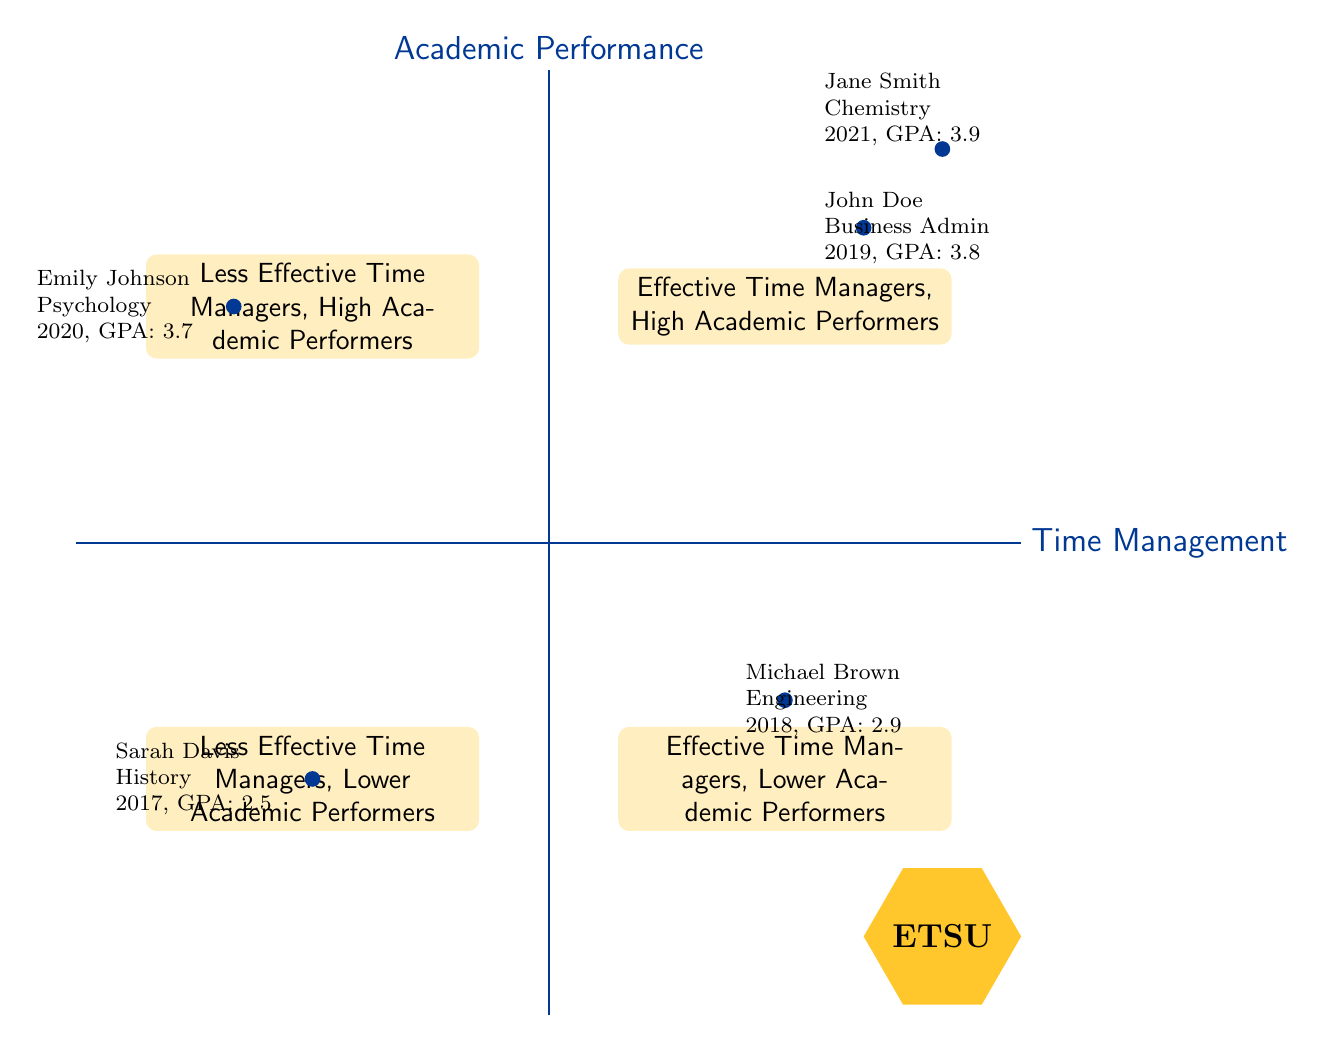What is the GPA of John Doe? According to the example provided in the Top-Right quadrant, John Doe's GPA is listed directly next to his name. Thus, the GPA information is clearly stated.
Answer: 3.8 Which quadrant contains Emily Johnson? Emily Johnson is located in the Top-Left quadrant, which represents "Less Effective Time Managers, High Academic Performers." Her position is indicated on the diagram as well as on her individual data label.
Answer: Top-Left How many students are categorized as "Effective Time Managers, Lower Academic Performers"? There is only one student example in the Bottom-Right quadrant labeled "Effective Time Managers, Lower Academic Performers;" this is Michael Brown. Counting the examples in that quadrant gives a total of one student.
Answer: 1 Who has the highest GPA among the students? To determine who has the highest GPA, we need to compare the GPAs listed for all students shown in each quadrant. The GPAs for John Doe, Jane Smith, and Emily Johnson are 3.8, 3.9, and 3.7, respectively. Jane Smith has the highest GPA at 3.9.
Answer: Jane Smith Which quadrant would you find Sarah Davis? Sarah Davis is placed in the Bottom-Left quadrant, which is designated as "Less Effective Time Managers, Lower Academic Performers." This can be found directly by consulting the designated quadrant and her associated label in that area.
Answer: Bottom-Left What sport do all the featured students participate in? Reviewing the provided data, all students mentioned are involved in basketball. Each student's basketball position is uniquely noted alongside their academic information.
Answer: Basketball Which major is linked with the highest performing student in the diagram? The highest performing student in the Top-Right quadrant is Jane Smith, and her major is Chemistry. This is confirmed by locating her data in the corresponding section of the diagram.
Answer: Chemistry What is the main issue that Sarah Davis faced according to her comment? Sarah Davis faced difficulty in managing her time between sports and studies, causing her to often procrastinate. This information can be found in her comments within the Bottom-Left quadrant.
Answer: Procrastination How many quadrants are used to categorize the students? The diagram utilizes four quadrants to categorize the students based on their time management skills and academic performance. This can be easily counted by observing the structure of the diagram itself.
Answer: 4 